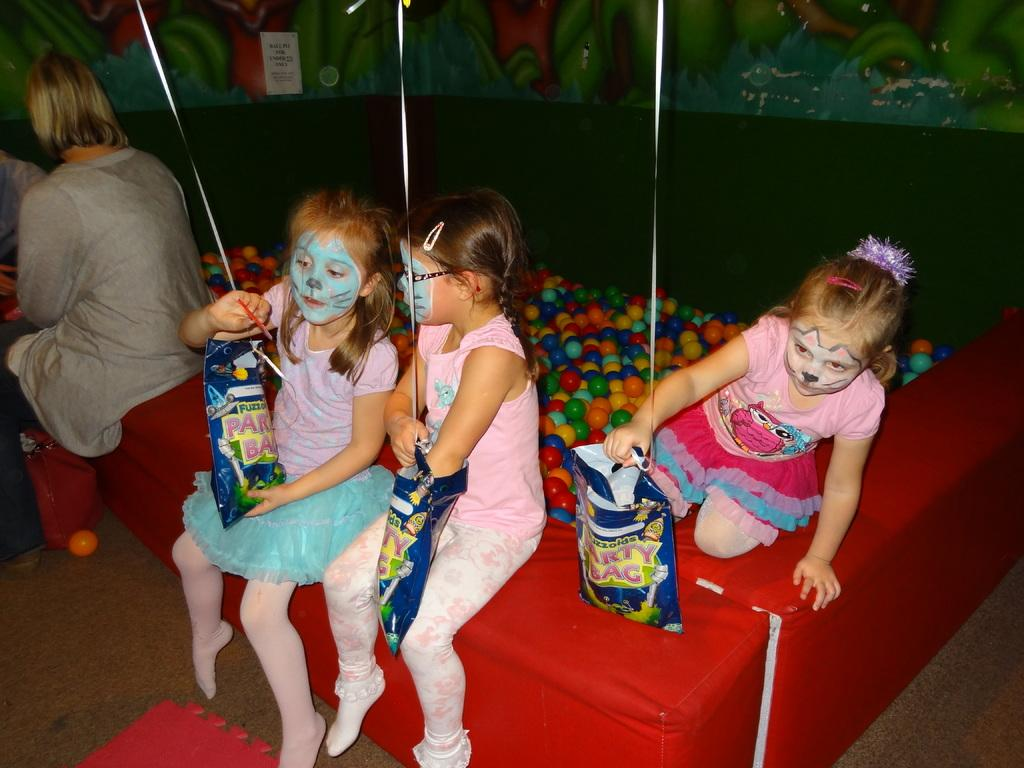What are the people in the image doing? The people in the image are sitting. What are the people holding in the image? The people are holding blue color bags. What else can be seen in the image besides the people and bags? There are balls visible in the image. What is on the wall in the image? There is a painting on the wall. What type of hydrant can be seen in the image? There is no hydrant present in the image. How many dimes are visible on the painting in the image? There is no mention of dimes or any currency in the image; the focus is on the people, bags, balls, and painting. 